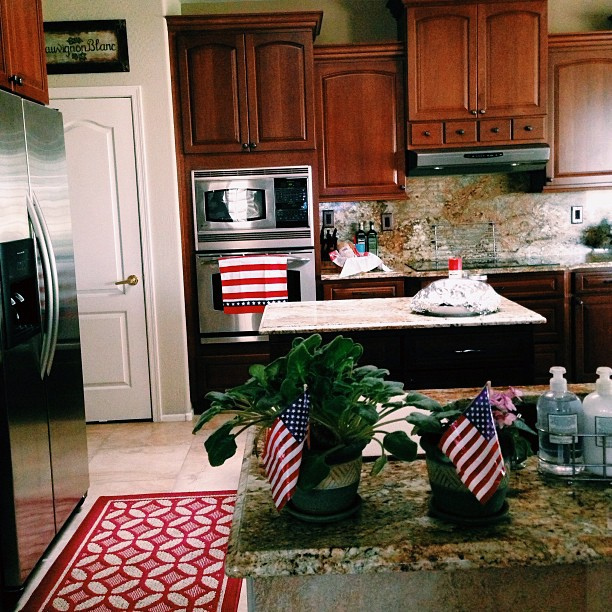Please extract the text content from this image. Blanc 